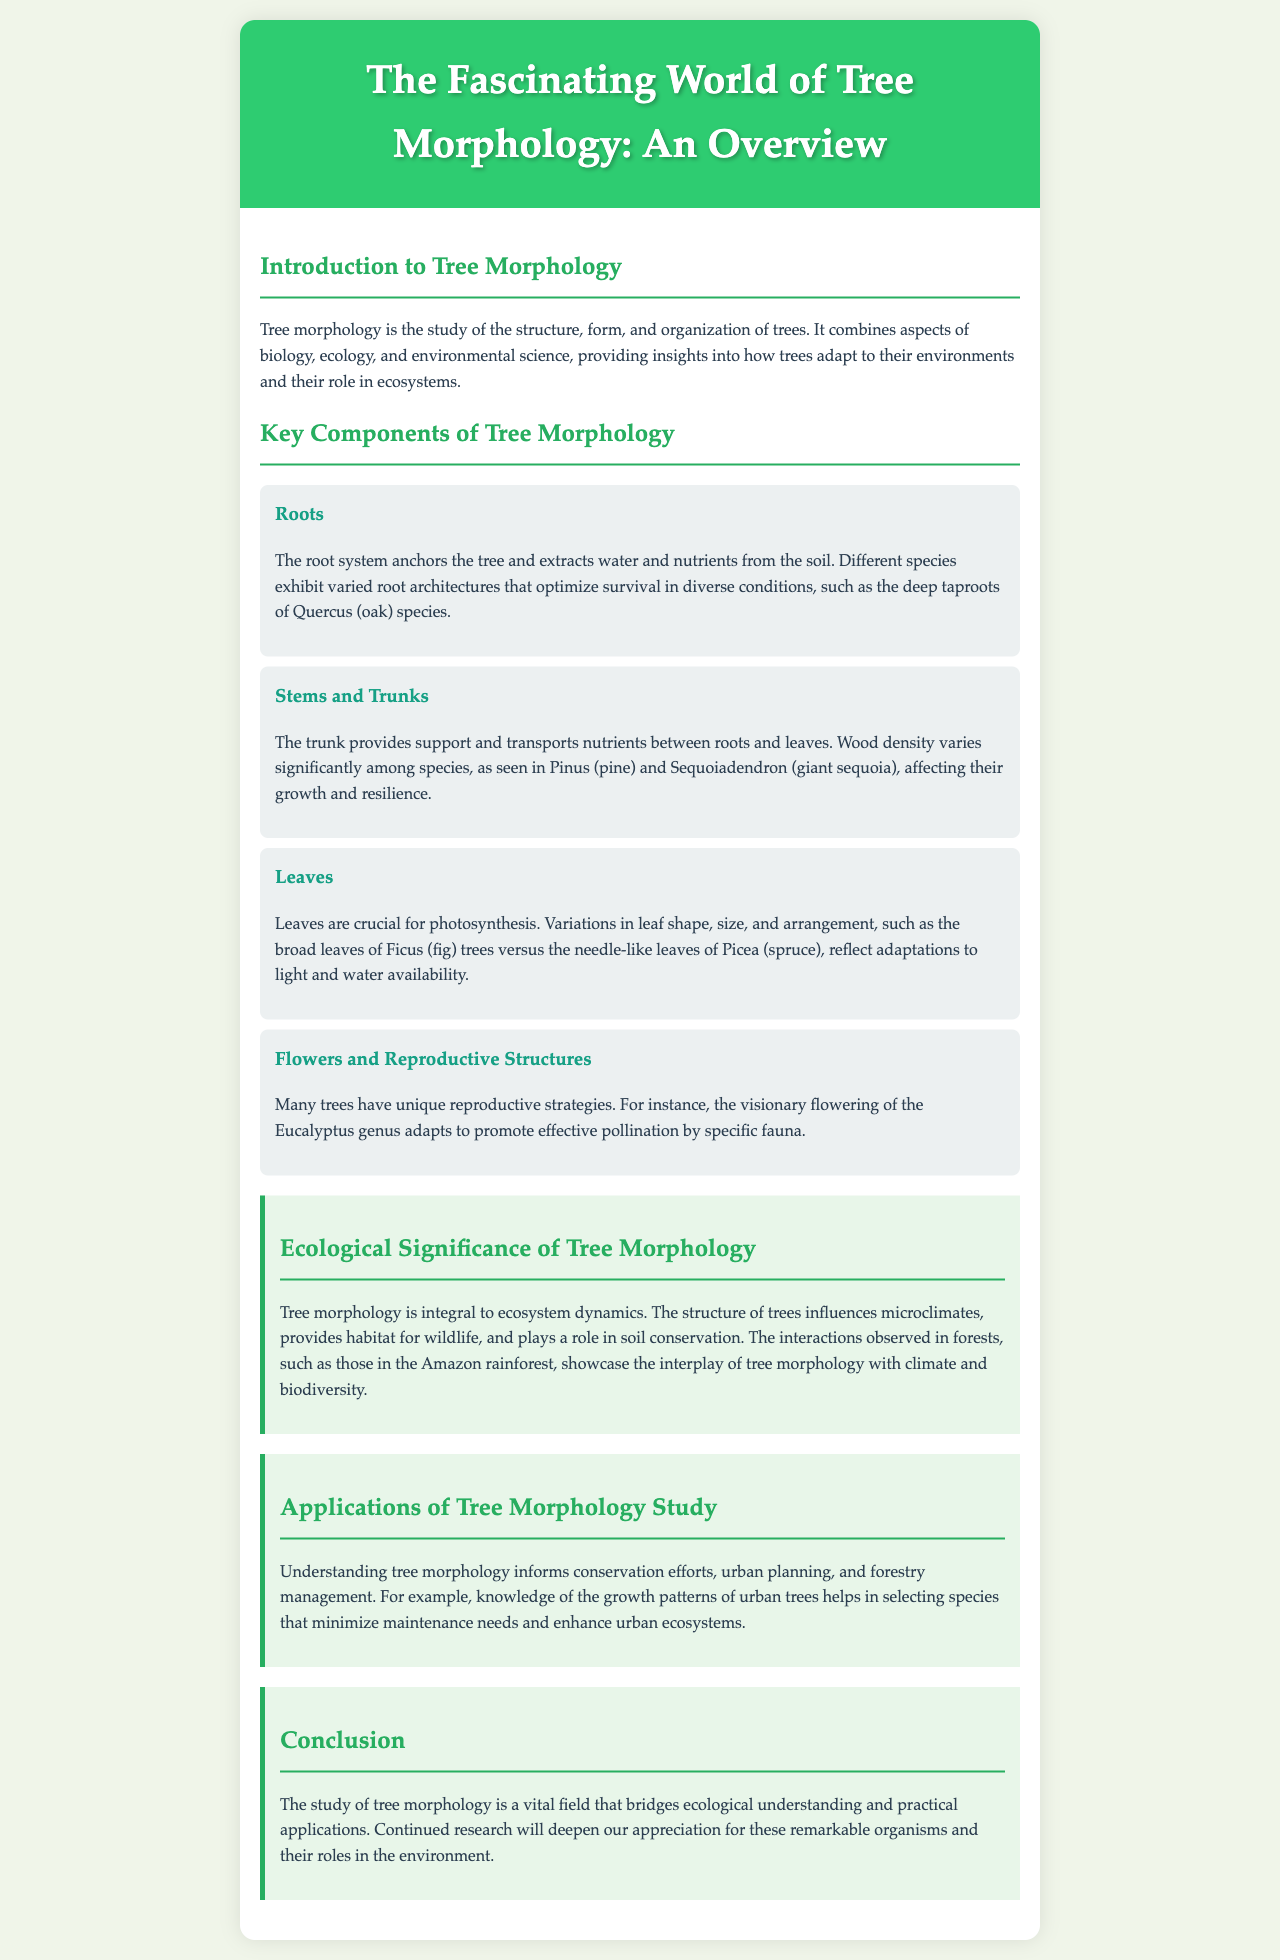What is tree morphology? Tree morphology is defined as the study of the structure, form, and organization of trees.
Answer: the study of the structure, form, and organization of trees What are the key components of tree morphology? The document lists four components: roots, stems and trunks, leaves, and flowers and reproductive structures.
Answer: roots, stems and trunks, leaves, flowers and reproductive structures What is the role of roots in trees? Roots anchor the tree and extract water and nutrients from the soil, exhibiting varied architectures.
Answer: anchor and extract water and nutrients Which genus is associated with deep taproots? The document mentions Quercus as having deep taproots.
Answer: Quercus How does tree morphology affect ecosystem dynamics? Tree morphology influences microclimates, provides habitat for wildlife, and plays a role in soil conservation.
Answer: influences microclimates, provides habitat, and plays a role in soil conservation What applications are informed by studying tree morphology? The document states that it informs conservation efforts, urban planning, and forestry management.
Answer: conservation efforts, urban planning, forestry management What unique flowering strategy is mentioned? Eucalyptus is noted for its unique flowering strategy promoting effective pollination.
Answer: Eucalyptus What type of document is this? The document is a brochure that provides an overview of tree morphology.
Answer: a brochure 